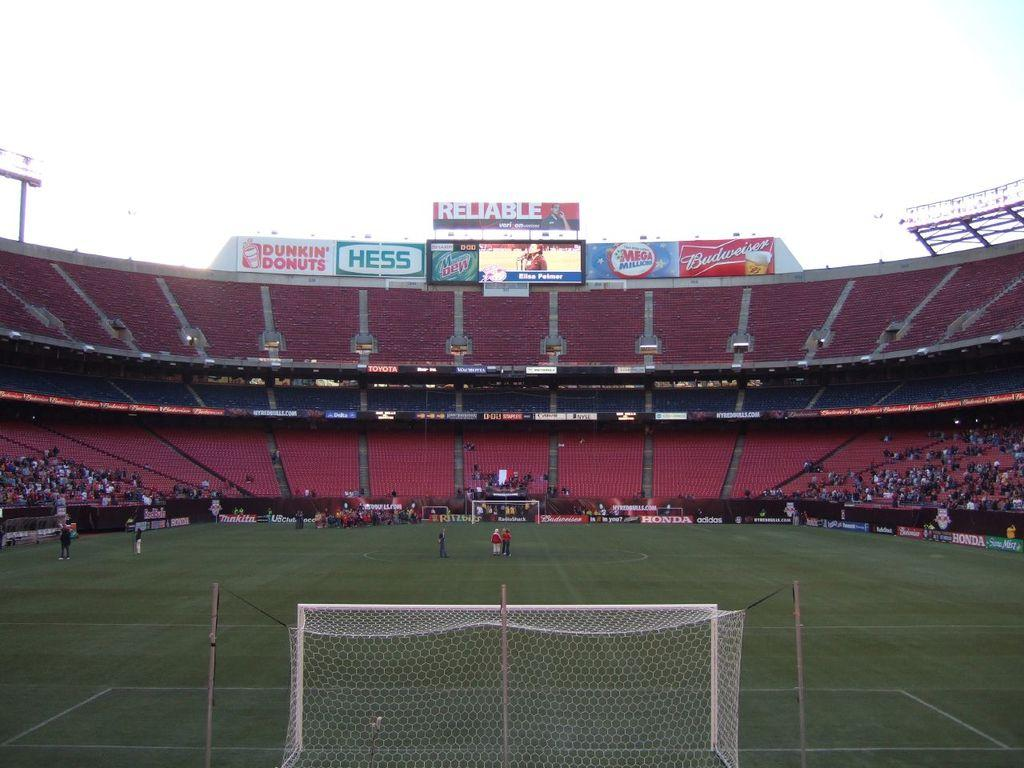Provide a one-sentence caption for the provided image. A large stadium with advertisements placed at the top for Dunkin Donuts and Hess. 